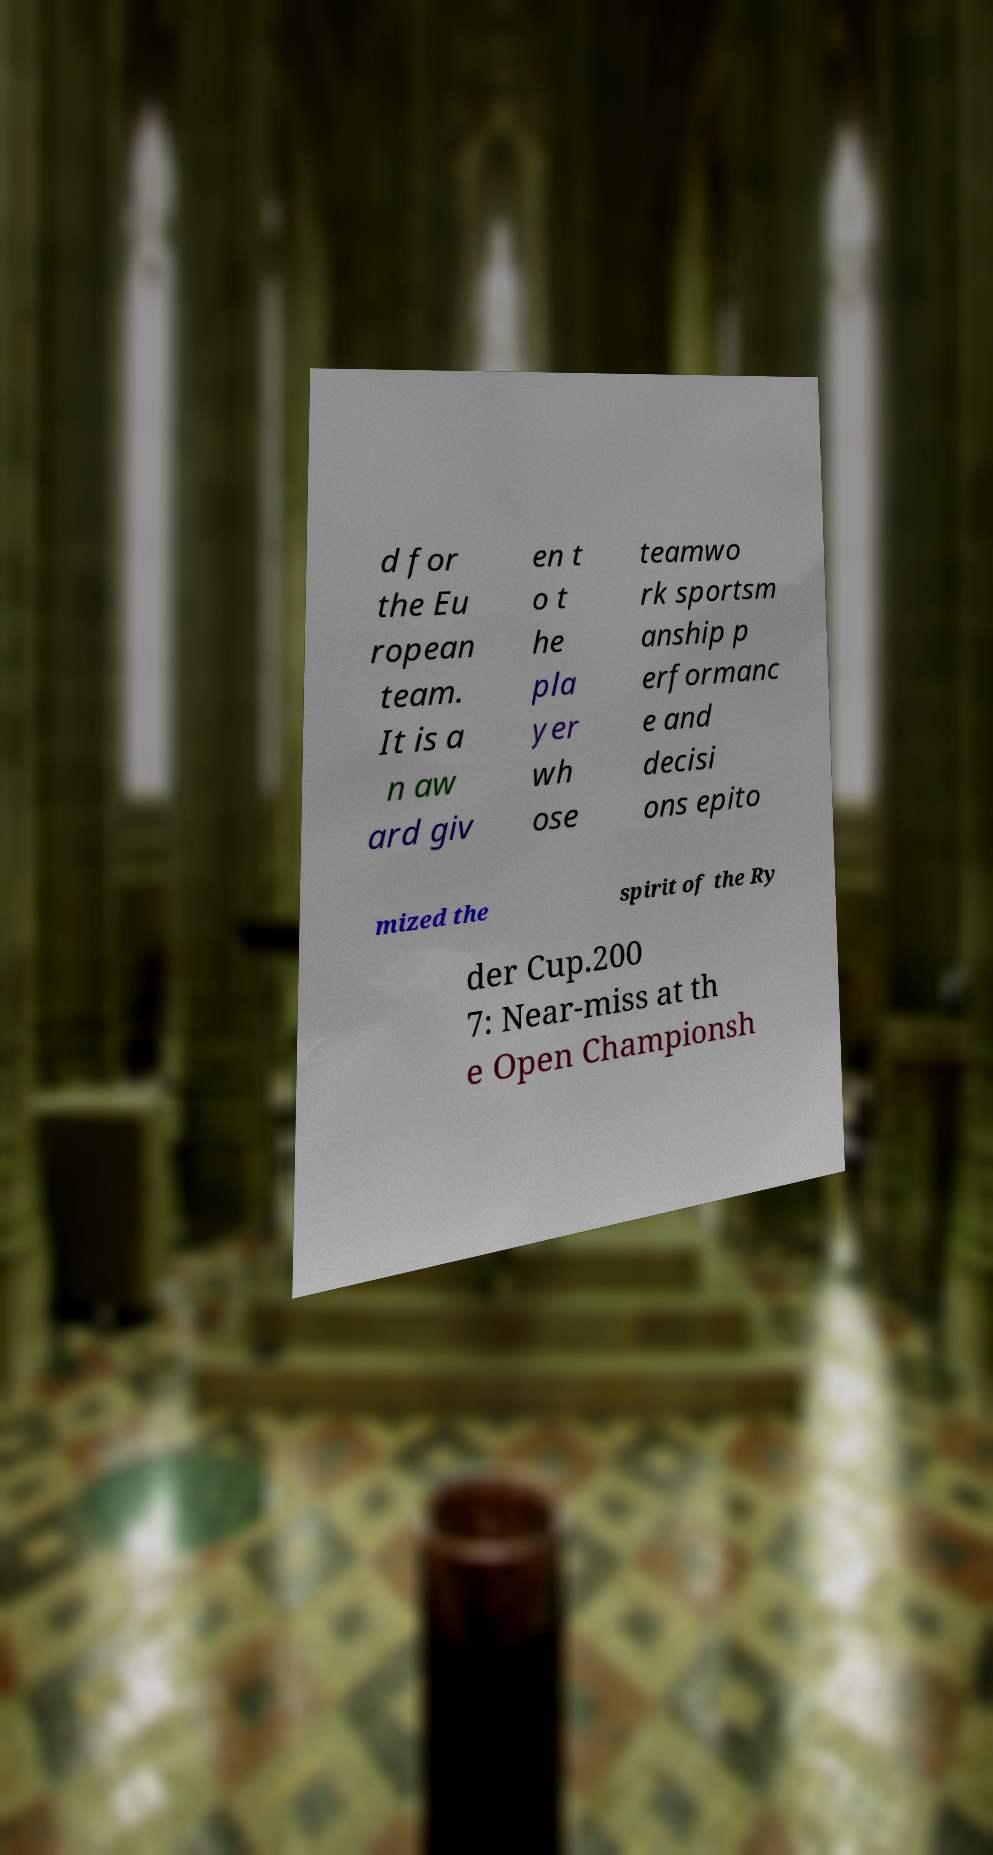For documentation purposes, I need the text within this image transcribed. Could you provide that? d for the Eu ropean team. It is a n aw ard giv en t o t he pla yer wh ose teamwo rk sportsm anship p erformanc e and decisi ons epito mized the spirit of the Ry der Cup.200 7: Near-miss at th e Open Championsh 